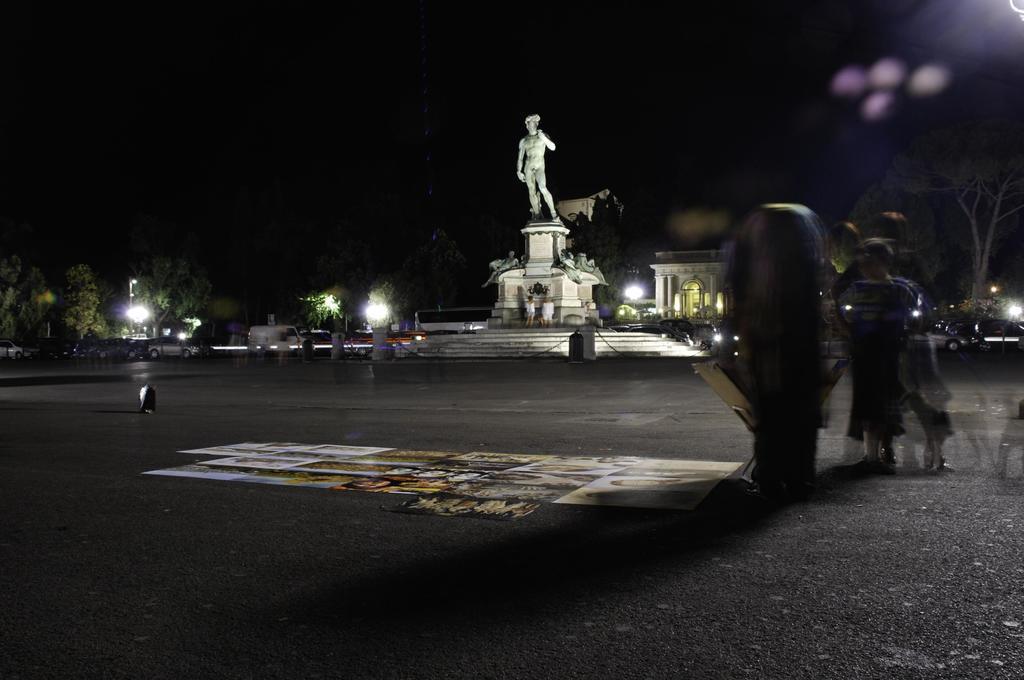In one or two sentences, can you explain what this image depicts? In this image on the right side there are some people and one dog, in the center there is one statue and some stairs and some persons. In the background there are some trees, lights and some vehicles. On the right side there are some buildings and plants and trees. At the bottom there is a road, on the road there is a painting. 